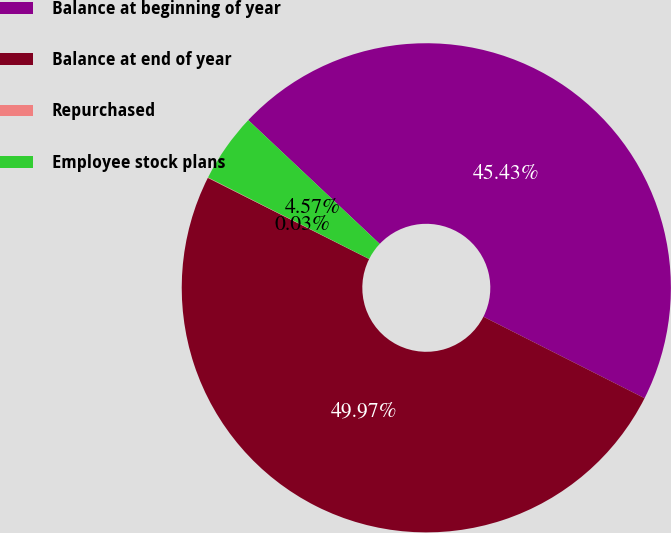Convert chart to OTSL. <chart><loc_0><loc_0><loc_500><loc_500><pie_chart><fcel>Balance at beginning of year<fcel>Balance at end of year<fcel>Repurchased<fcel>Employee stock plans<nl><fcel>45.43%<fcel>49.97%<fcel>0.03%<fcel>4.57%<nl></chart> 